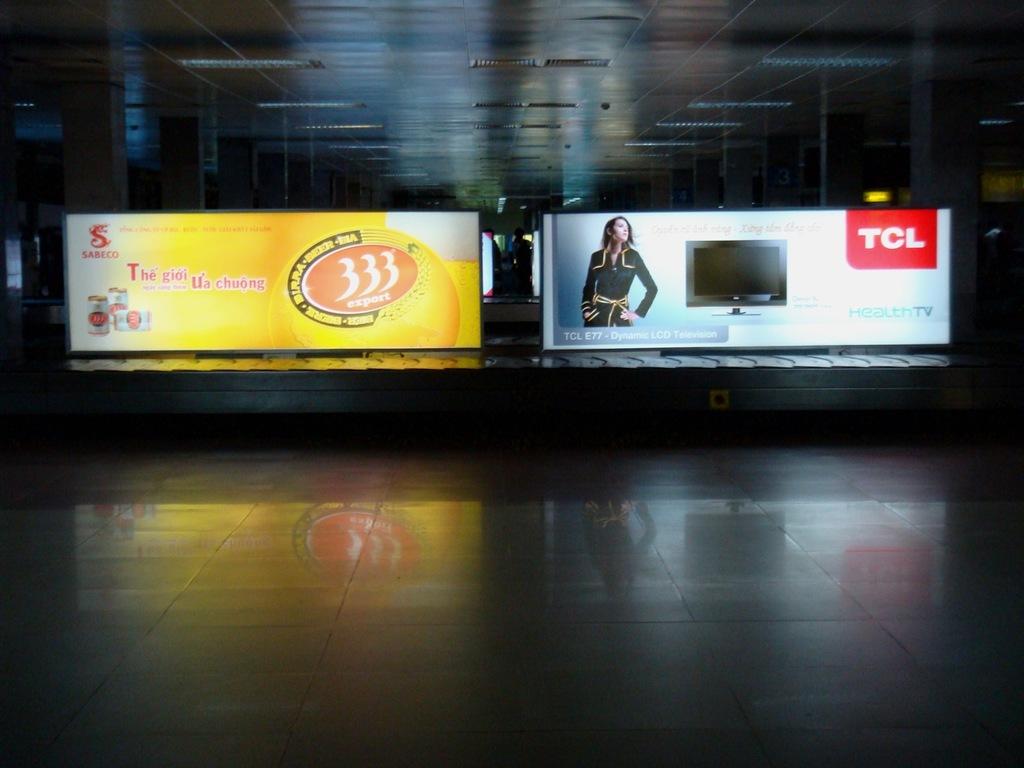What lgo is on the top right of the bench?
Keep it short and to the point. Tcl. What is the three digit number?
Your response must be concise. 333. 